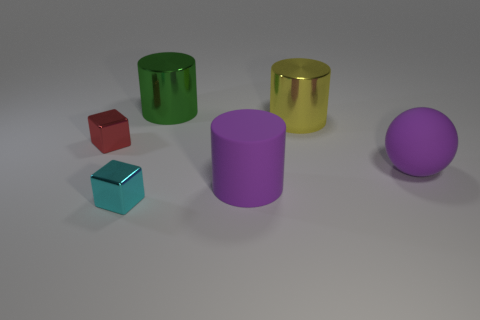Does the large sphere on the right side of the green shiny cylinder have the same material as the large purple cylinder?
Your answer should be compact. Yes. What size is the block that is behind the matte cylinder that is behind the small metal object that is right of the red shiny block?
Your answer should be very brief. Small. There is a purple object that is the same material as the big purple ball; what size is it?
Your answer should be very brief. Large. What is the color of the cylinder that is behind the purple cylinder and in front of the large green metal thing?
Ensure brevity in your answer.  Yellow. There is a purple rubber thing on the right side of the big yellow object; does it have the same shape as the green metallic thing that is behind the yellow thing?
Your answer should be compact. No. What is the small cube that is behind the matte ball made of?
Offer a terse response. Metal. There is a matte cylinder that is the same color as the big matte ball; what size is it?
Make the answer very short. Large. What number of objects are either purple things that are in front of the big purple sphere or big brown matte things?
Ensure brevity in your answer.  1. Are there an equal number of tiny red objects right of the tiny cyan cube and large yellow metal spheres?
Give a very brief answer. Yes. Do the cyan metallic block and the red metal block have the same size?
Offer a very short reply. Yes. 